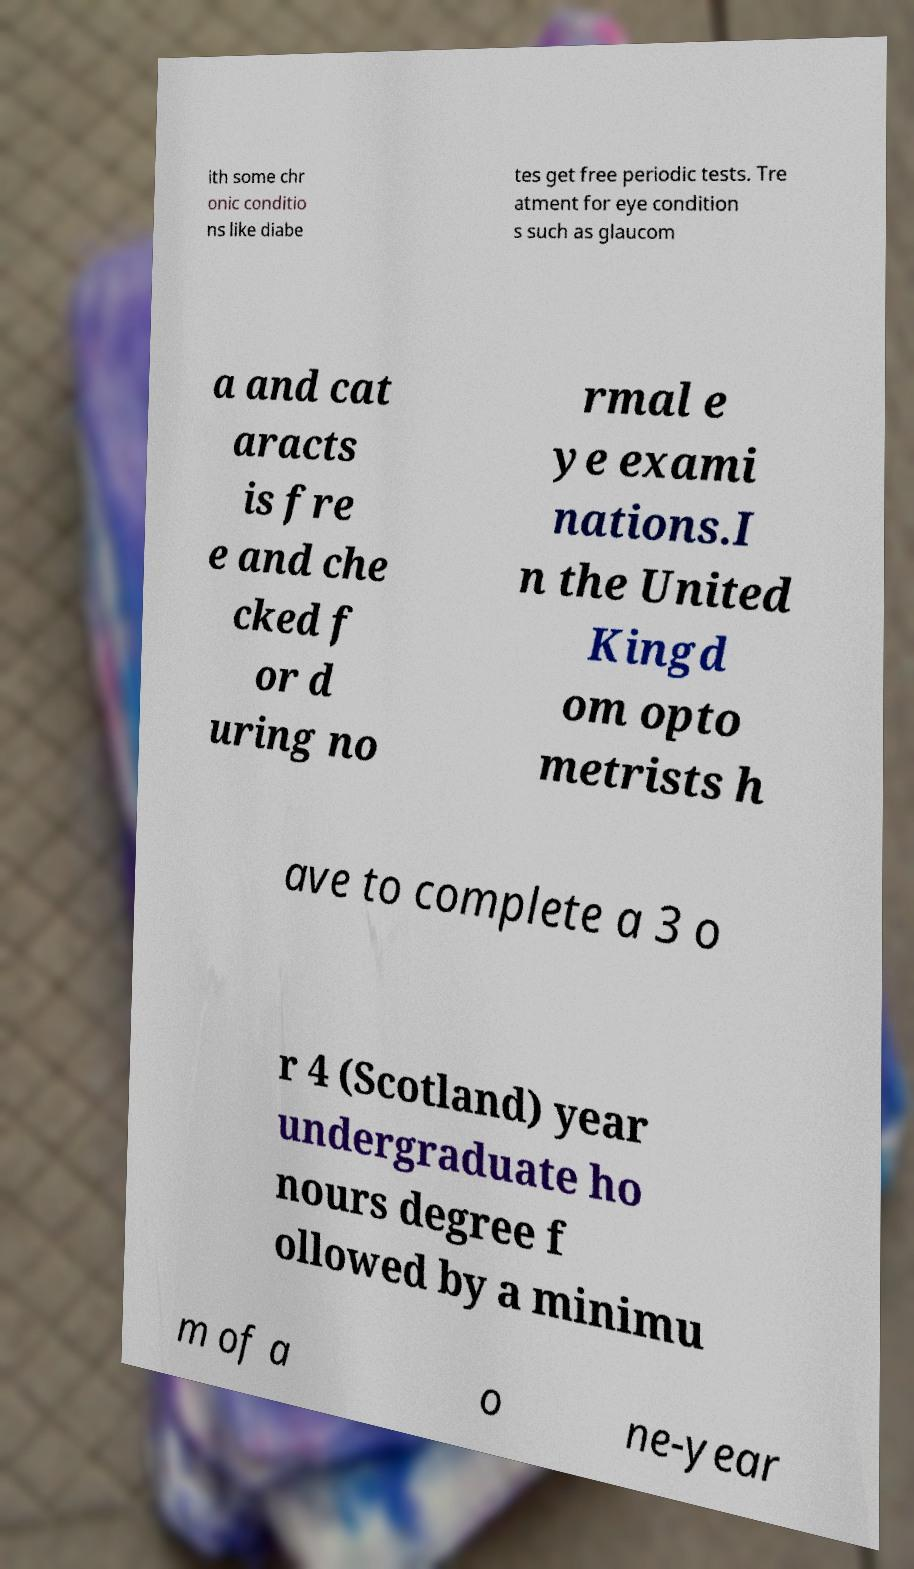Could you assist in decoding the text presented in this image and type it out clearly? ith some chr onic conditio ns like diabe tes get free periodic tests. Tre atment for eye condition s such as glaucom a and cat aracts is fre e and che cked f or d uring no rmal e ye exami nations.I n the United Kingd om opto metrists h ave to complete a 3 o r 4 (Scotland) year undergraduate ho nours degree f ollowed by a minimu m of a o ne-year 